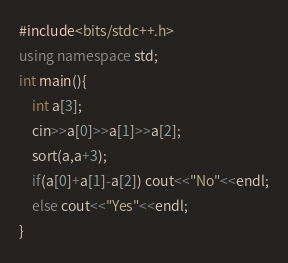Convert code to text. <code><loc_0><loc_0><loc_500><loc_500><_C++_>#include<bits/stdc++.h>
using namespace std;
int main(){
    int a[3];
    cin>>a[0]>>a[1]>>a[2];
    sort(a,a+3);
    if(a[0]+a[1]-a[2]) cout<<"No"<<endl;
    else cout<<"Yes"<<endl;
}</code> 